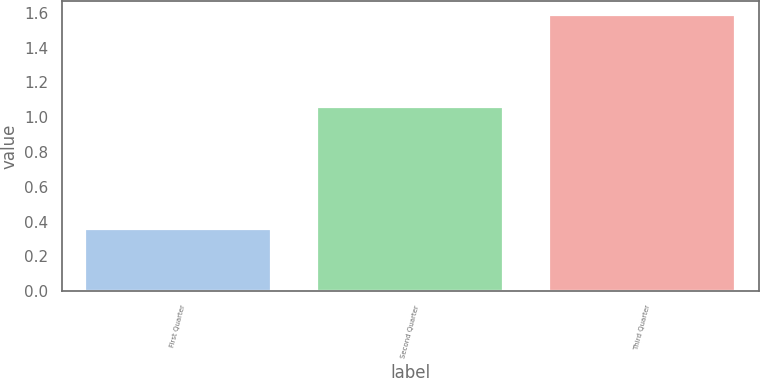<chart> <loc_0><loc_0><loc_500><loc_500><bar_chart><fcel>First Quarter<fcel>Second Quarter<fcel>Third Quarter<nl><fcel>0.36<fcel>1.06<fcel>1.59<nl></chart> 